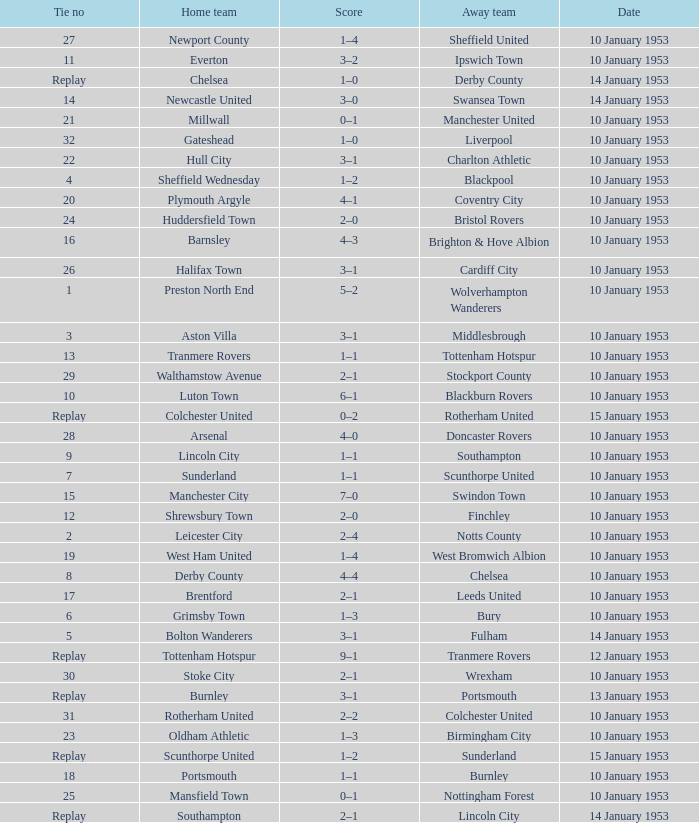What home team has coventry city as the away team? Plymouth Argyle. 